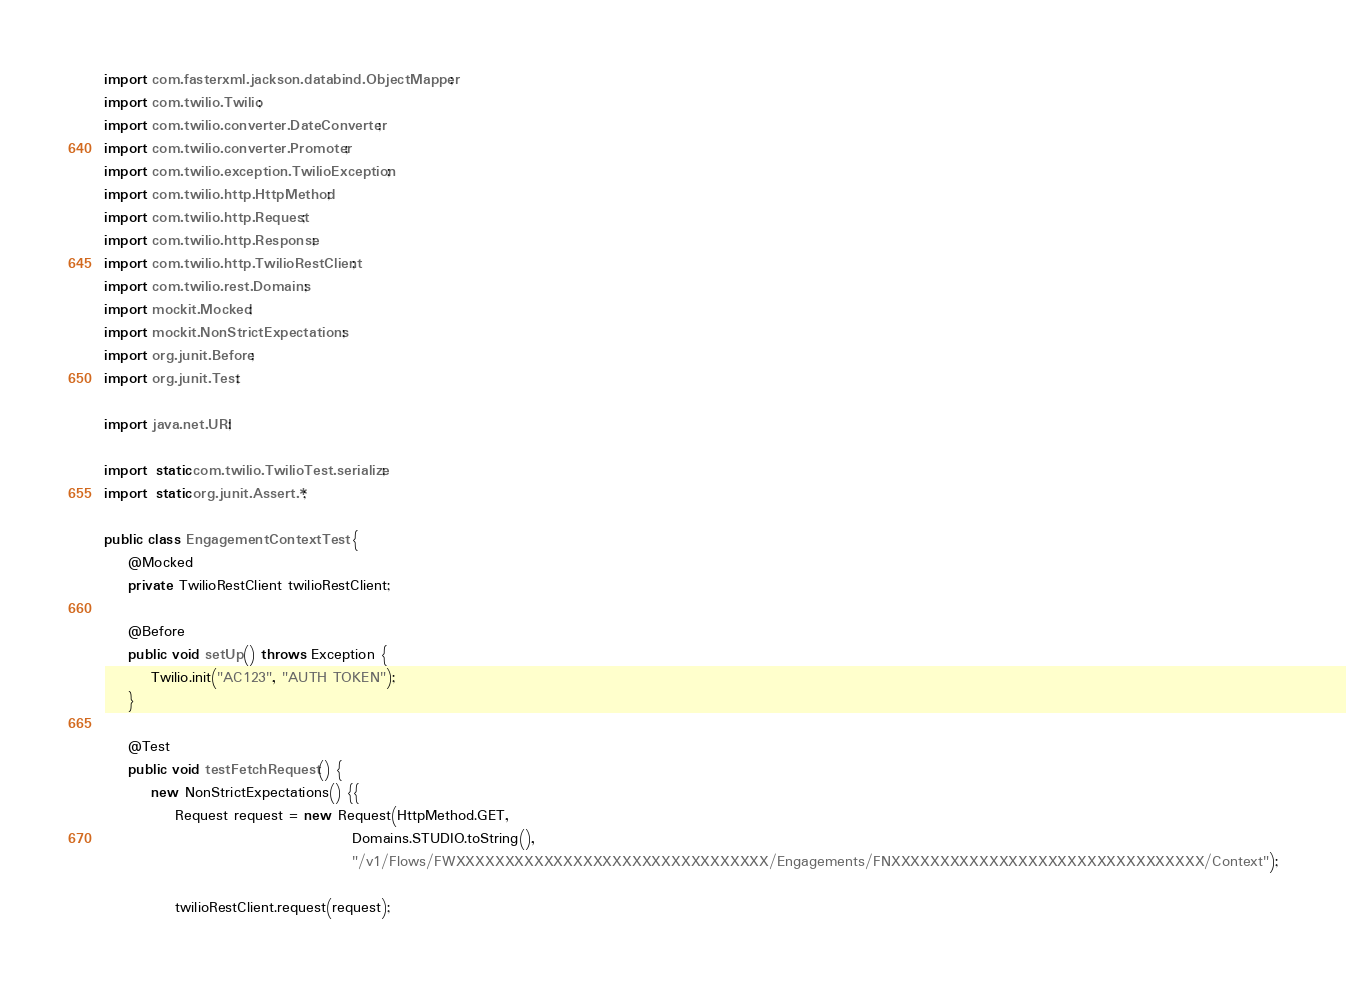Convert code to text. <code><loc_0><loc_0><loc_500><loc_500><_Java_>
import com.fasterxml.jackson.databind.ObjectMapper;
import com.twilio.Twilio;
import com.twilio.converter.DateConverter;
import com.twilio.converter.Promoter;
import com.twilio.exception.TwilioException;
import com.twilio.http.HttpMethod;
import com.twilio.http.Request;
import com.twilio.http.Response;
import com.twilio.http.TwilioRestClient;
import com.twilio.rest.Domains;
import mockit.Mocked;
import mockit.NonStrictExpectations;
import org.junit.Before;
import org.junit.Test;

import java.net.URI;

import static com.twilio.TwilioTest.serialize;
import static org.junit.Assert.*;

public class EngagementContextTest {
    @Mocked
    private TwilioRestClient twilioRestClient;

    @Before
    public void setUp() throws Exception {
        Twilio.init("AC123", "AUTH TOKEN");
    }

    @Test
    public void testFetchRequest() {
        new NonStrictExpectations() {{
            Request request = new Request(HttpMethod.GET,
                                          Domains.STUDIO.toString(),
                                          "/v1/Flows/FWXXXXXXXXXXXXXXXXXXXXXXXXXXXXXXXX/Engagements/FNXXXXXXXXXXXXXXXXXXXXXXXXXXXXXXXX/Context");
            
            twilioRestClient.request(request);</code> 